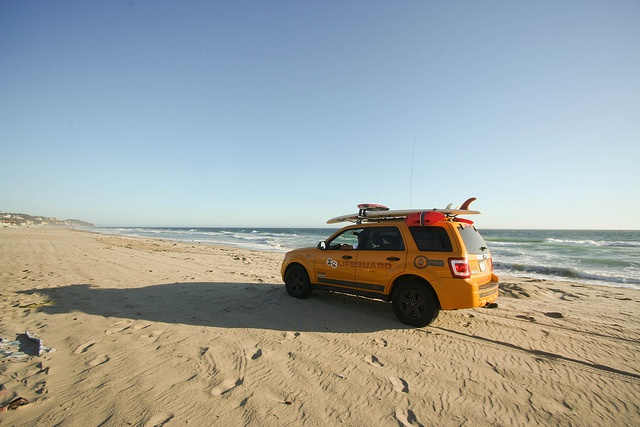Describe the objects in this image and their specific colors. I can see car in gray, black, brown, and maroon tones, surfboard in gray, darkgray, and maroon tones, and people in gray, black, maroon, and darkgray tones in this image. 